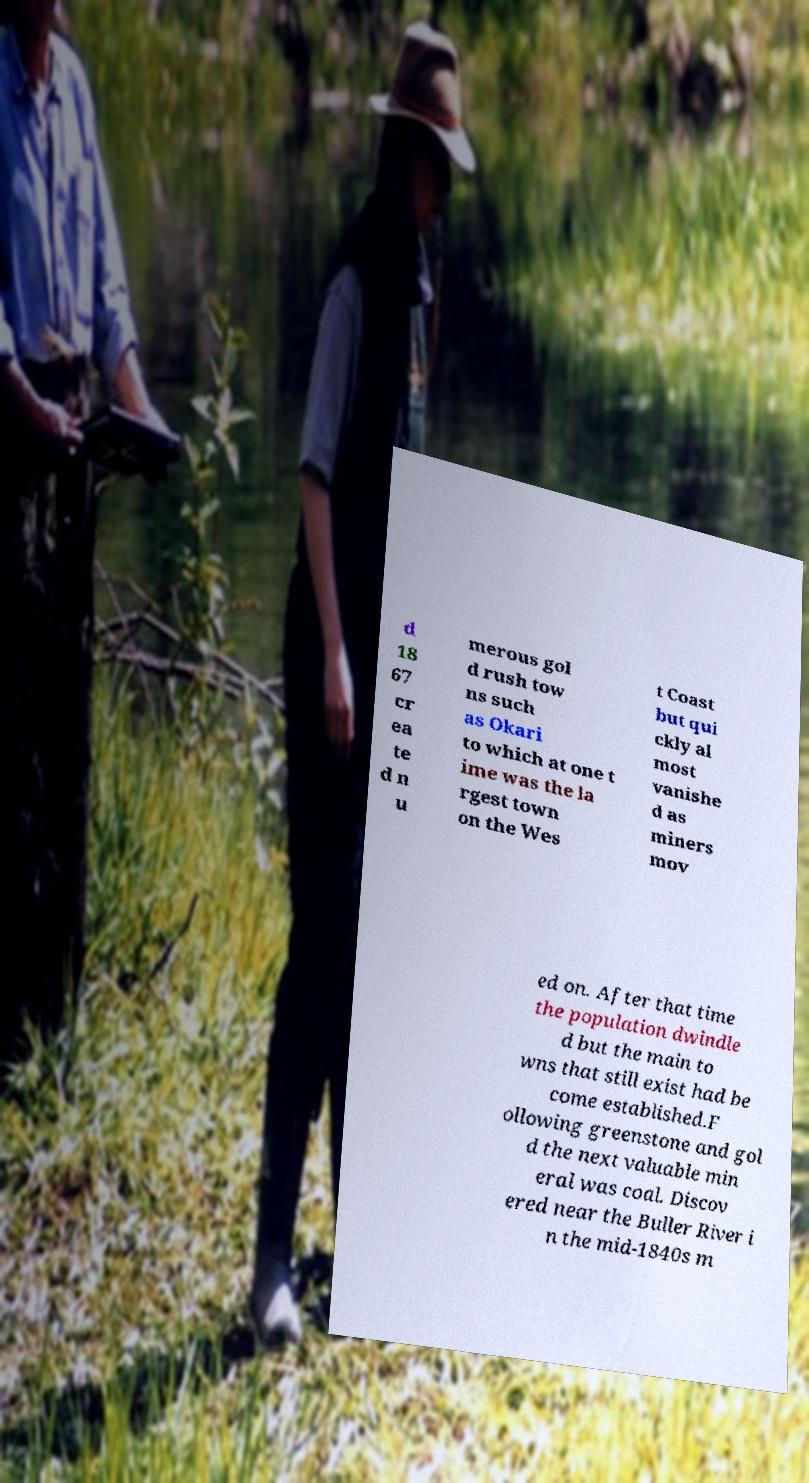I need the written content from this picture converted into text. Can you do that? d 18 67 cr ea te d n u merous gol d rush tow ns such as Okari to which at one t ime was the la rgest town on the Wes t Coast but qui ckly al most vanishe d as miners mov ed on. After that time the population dwindle d but the main to wns that still exist had be come established.F ollowing greenstone and gol d the next valuable min eral was coal. Discov ered near the Buller River i n the mid-1840s m 